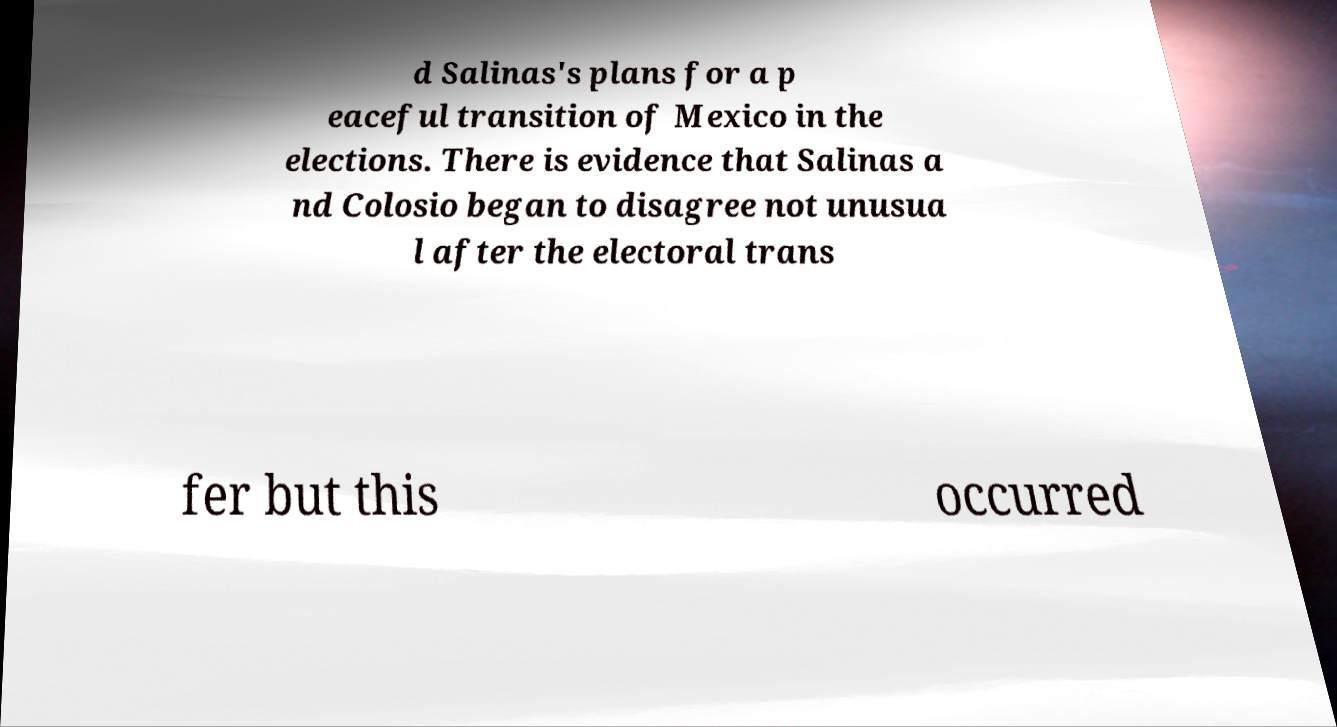There's text embedded in this image that I need extracted. Can you transcribe it verbatim? d Salinas's plans for a p eaceful transition of Mexico in the elections. There is evidence that Salinas a nd Colosio began to disagree not unusua l after the electoral trans fer but this occurred 